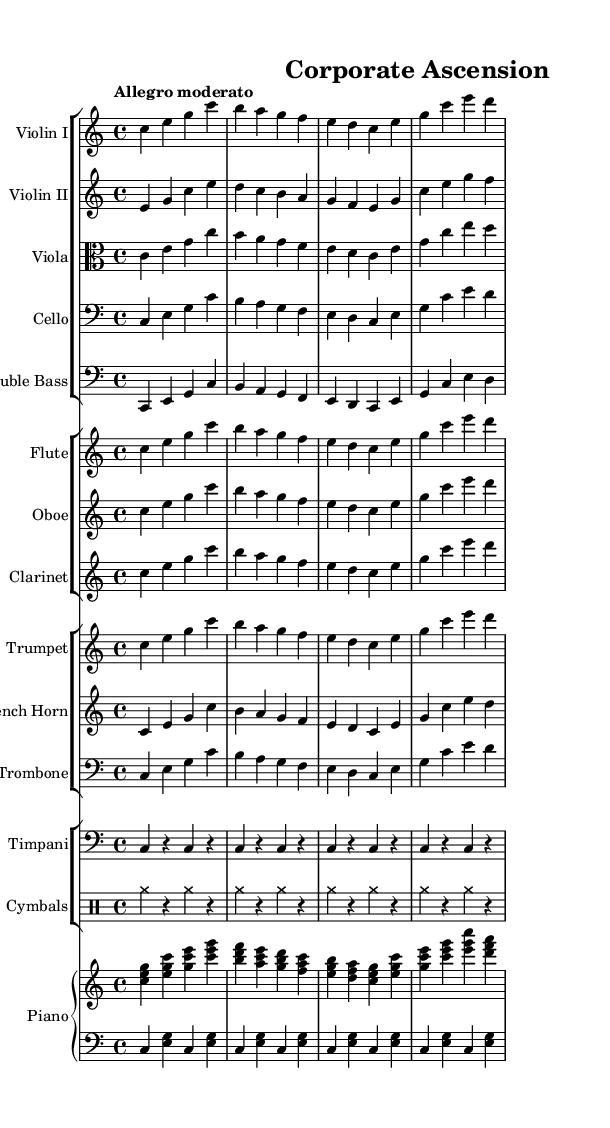What is the key signature of this music? The key signature is C major, which has no sharps or flats indicated in the music. The clefs and notes also support this key signature.
Answer: C major What is the time signature of this piece? The time signature is found at the beginning of the music, which is set to 4/4, meaning there are four beats per measure.
Answer: 4/4 What is the tempo marking for this score? The tempo marking reads "Allegro moderato," which instructs the musicians to play at a moderately fast pace.
Answer: Allegro moderato How many measures are identified in the vocal sections? Counting the number of complete measures in the various instrumental sections yields a total of eight measures.
Answer: 8 Which instruments are included in the woodwind section? The woodwind section consists of flute, oboe, and clarinet, as evident from the designated staves in the score.
Answer: Flute, Oboe, Clarinet What rhythmic pattern is primarily established in the timpani? The timpani part features a repeated pattern of quarter notes followed by rests, creating a steady rhythmic foundation throughout the measures.
Answer: Quarter notes with rests In which section does the piano play? The piano is included as part of the score, designated in its own staff group and marked as a Piano staff, playing both right and left hand parts.
Answer: Piano 